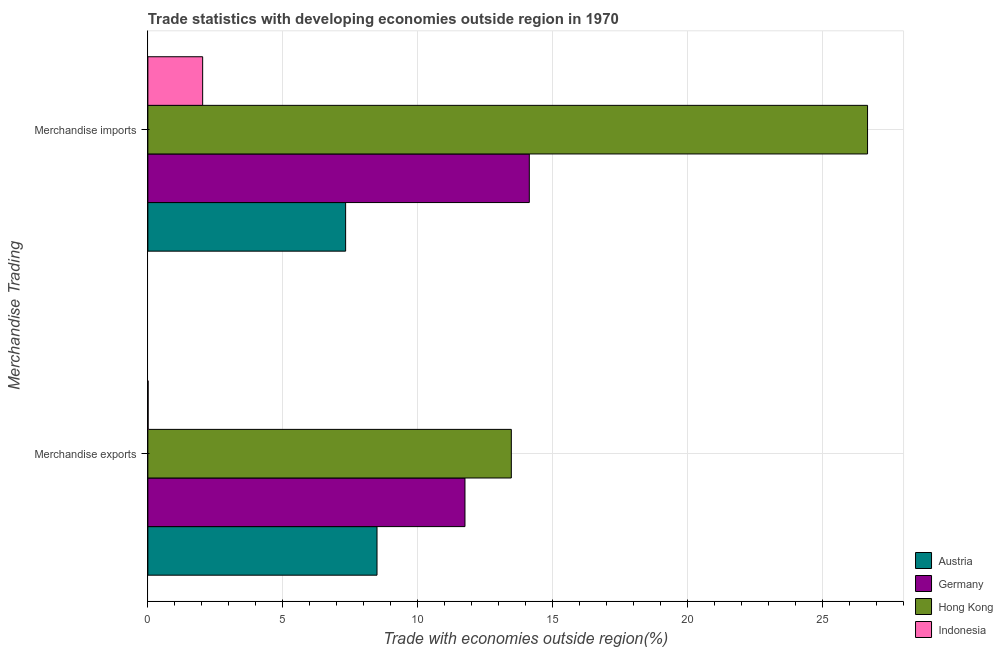How many different coloured bars are there?
Ensure brevity in your answer.  4. How many groups of bars are there?
Keep it short and to the point. 2. Are the number of bars on each tick of the Y-axis equal?
Provide a succinct answer. Yes. What is the label of the 1st group of bars from the top?
Your answer should be very brief. Merchandise imports. What is the merchandise imports in Indonesia?
Ensure brevity in your answer.  2.03. Across all countries, what is the maximum merchandise exports?
Provide a succinct answer. 13.47. Across all countries, what is the minimum merchandise imports?
Offer a terse response. 2.03. In which country was the merchandise imports maximum?
Offer a very short reply. Hong Kong. What is the total merchandise imports in the graph?
Ensure brevity in your answer.  50.18. What is the difference between the merchandise exports in Indonesia and that in Austria?
Your answer should be very brief. -8.49. What is the difference between the merchandise imports in Austria and the merchandise exports in Indonesia?
Offer a terse response. 7.32. What is the average merchandise imports per country?
Your answer should be compact. 12.55. What is the difference between the merchandise imports and merchandise exports in Hong Kong?
Make the answer very short. 13.21. In how many countries, is the merchandise exports greater than 14 %?
Offer a very short reply. 0. What is the ratio of the merchandise exports in Hong Kong to that in Germany?
Keep it short and to the point. 1.15. Is the merchandise exports in Germany less than that in Indonesia?
Give a very brief answer. No. What does the 1st bar from the top in Merchandise imports represents?
Ensure brevity in your answer.  Indonesia. How many bars are there?
Provide a succinct answer. 8. What is the difference between two consecutive major ticks on the X-axis?
Ensure brevity in your answer.  5. Are the values on the major ticks of X-axis written in scientific E-notation?
Give a very brief answer. No. Does the graph contain any zero values?
Offer a very short reply. No. How many legend labels are there?
Provide a short and direct response. 4. What is the title of the graph?
Provide a short and direct response. Trade statistics with developing economies outside region in 1970. What is the label or title of the X-axis?
Offer a very short reply. Trade with economies outside region(%). What is the label or title of the Y-axis?
Provide a succinct answer. Merchandise Trading. What is the Trade with economies outside region(%) of Austria in Merchandise exports?
Your answer should be very brief. 8.49. What is the Trade with economies outside region(%) in Germany in Merchandise exports?
Your response must be concise. 11.76. What is the Trade with economies outside region(%) in Hong Kong in Merchandise exports?
Offer a very short reply. 13.47. What is the Trade with economies outside region(%) of Indonesia in Merchandise exports?
Offer a terse response. 0.01. What is the Trade with economies outside region(%) in Austria in Merchandise imports?
Your answer should be compact. 7.33. What is the Trade with economies outside region(%) in Germany in Merchandise imports?
Your answer should be compact. 14.14. What is the Trade with economies outside region(%) in Hong Kong in Merchandise imports?
Your answer should be very brief. 26.68. What is the Trade with economies outside region(%) of Indonesia in Merchandise imports?
Provide a succinct answer. 2.03. Across all Merchandise Trading, what is the maximum Trade with economies outside region(%) of Austria?
Your response must be concise. 8.49. Across all Merchandise Trading, what is the maximum Trade with economies outside region(%) in Germany?
Offer a very short reply. 14.14. Across all Merchandise Trading, what is the maximum Trade with economies outside region(%) in Hong Kong?
Keep it short and to the point. 26.68. Across all Merchandise Trading, what is the maximum Trade with economies outside region(%) in Indonesia?
Your response must be concise. 2.03. Across all Merchandise Trading, what is the minimum Trade with economies outside region(%) of Austria?
Provide a short and direct response. 7.33. Across all Merchandise Trading, what is the minimum Trade with economies outside region(%) in Germany?
Your answer should be compact. 11.76. Across all Merchandise Trading, what is the minimum Trade with economies outside region(%) of Hong Kong?
Keep it short and to the point. 13.47. Across all Merchandise Trading, what is the minimum Trade with economies outside region(%) in Indonesia?
Keep it short and to the point. 0.01. What is the total Trade with economies outside region(%) of Austria in the graph?
Your response must be concise. 15.83. What is the total Trade with economies outside region(%) in Germany in the graph?
Your answer should be compact. 25.9. What is the total Trade with economies outside region(%) of Hong Kong in the graph?
Ensure brevity in your answer.  40.15. What is the total Trade with economies outside region(%) of Indonesia in the graph?
Your response must be concise. 2.04. What is the difference between the Trade with economies outside region(%) in Austria in Merchandise exports and that in Merchandise imports?
Offer a very short reply. 1.16. What is the difference between the Trade with economies outside region(%) of Germany in Merchandise exports and that in Merchandise imports?
Make the answer very short. -2.38. What is the difference between the Trade with economies outside region(%) in Hong Kong in Merchandise exports and that in Merchandise imports?
Offer a very short reply. -13.21. What is the difference between the Trade with economies outside region(%) in Indonesia in Merchandise exports and that in Merchandise imports?
Ensure brevity in your answer.  -2.02. What is the difference between the Trade with economies outside region(%) of Austria in Merchandise exports and the Trade with economies outside region(%) of Germany in Merchandise imports?
Your answer should be very brief. -5.65. What is the difference between the Trade with economies outside region(%) of Austria in Merchandise exports and the Trade with economies outside region(%) of Hong Kong in Merchandise imports?
Give a very brief answer. -18.18. What is the difference between the Trade with economies outside region(%) in Austria in Merchandise exports and the Trade with economies outside region(%) in Indonesia in Merchandise imports?
Your answer should be very brief. 6.46. What is the difference between the Trade with economies outside region(%) of Germany in Merchandise exports and the Trade with economies outside region(%) of Hong Kong in Merchandise imports?
Provide a short and direct response. -14.92. What is the difference between the Trade with economies outside region(%) of Germany in Merchandise exports and the Trade with economies outside region(%) of Indonesia in Merchandise imports?
Provide a short and direct response. 9.72. What is the difference between the Trade with economies outside region(%) of Hong Kong in Merchandise exports and the Trade with economies outside region(%) of Indonesia in Merchandise imports?
Offer a terse response. 11.44. What is the average Trade with economies outside region(%) in Austria per Merchandise Trading?
Your response must be concise. 7.91. What is the average Trade with economies outside region(%) of Germany per Merchandise Trading?
Your response must be concise. 12.95. What is the average Trade with economies outside region(%) in Hong Kong per Merchandise Trading?
Make the answer very short. 20.08. What is the average Trade with economies outside region(%) of Indonesia per Merchandise Trading?
Keep it short and to the point. 1.02. What is the difference between the Trade with economies outside region(%) in Austria and Trade with economies outside region(%) in Germany in Merchandise exports?
Your answer should be compact. -3.26. What is the difference between the Trade with economies outside region(%) in Austria and Trade with economies outside region(%) in Hong Kong in Merchandise exports?
Provide a short and direct response. -4.98. What is the difference between the Trade with economies outside region(%) of Austria and Trade with economies outside region(%) of Indonesia in Merchandise exports?
Make the answer very short. 8.49. What is the difference between the Trade with economies outside region(%) of Germany and Trade with economies outside region(%) of Hong Kong in Merchandise exports?
Give a very brief answer. -1.72. What is the difference between the Trade with economies outside region(%) of Germany and Trade with economies outside region(%) of Indonesia in Merchandise exports?
Your response must be concise. 11.75. What is the difference between the Trade with economies outside region(%) of Hong Kong and Trade with economies outside region(%) of Indonesia in Merchandise exports?
Give a very brief answer. 13.47. What is the difference between the Trade with economies outside region(%) in Austria and Trade with economies outside region(%) in Germany in Merchandise imports?
Give a very brief answer. -6.81. What is the difference between the Trade with economies outside region(%) of Austria and Trade with economies outside region(%) of Hong Kong in Merchandise imports?
Offer a very short reply. -19.35. What is the difference between the Trade with economies outside region(%) in Austria and Trade with economies outside region(%) in Indonesia in Merchandise imports?
Your answer should be very brief. 5.3. What is the difference between the Trade with economies outside region(%) of Germany and Trade with economies outside region(%) of Hong Kong in Merchandise imports?
Keep it short and to the point. -12.54. What is the difference between the Trade with economies outside region(%) in Germany and Trade with economies outside region(%) in Indonesia in Merchandise imports?
Offer a terse response. 12.11. What is the difference between the Trade with economies outside region(%) of Hong Kong and Trade with economies outside region(%) of Indonesia in Merchandise imports?
Offer a very short reply. 24.65. What is the ratio of the Trade with economies outside region(%) in Austria in Merchandise exports to that in Merchandise imports?
Offer a terse response. 1.16. What is the ratio of the Trade with economies outside region(%) of Germany in Merchandise exports to that in Merchandise imports?
Your answer should be compact. 0.83. What is the ratio of the Trade with economies outside region(%) of Hong Kong in Merchandise exports to that in Merchandise imports?
Ensure brevity in your answer.  0.51. What is the ratio of the Trade with economies outside region(%) in Indonesia in Merchandise exports to that in Merchandise imports?
Offer a very short reply. 0. What is the difference between the highest and the second highest Trade with economies outside region(%) of Austria?
Your response must be concise. 1.16. What is the difference between the highest and the second highest Trade with economies outside region(%) in Germany?
Offer a very short reply. 2.38. What is the difference between the highest and the second highest Trade with economies outside region(%) of Hong Kong?
Offer a very short reply. 13.21. What is the difference between the highest and the second highest Trade with economies outside region(%) in Indonesia?
Offer a terse response. 2.02. What is the difference between the highest and the lowest Trade with economies outside region(%) of Austria?
Provide a short and direct response. 1.16. What is the difference between the highest and the lowest Trade with economies outside region(%) of Germany?
Keep it short and to the point. 2.38. What is the difference between the highest and the lowest Trade with economies outside region(%) of Hong Kong?
Keep it short and to the point. 13.21. What is the difference between the highest and the lowest Trade with economies outside region(%) of Indonesia?
Keep it short and to the point. 2.02. 